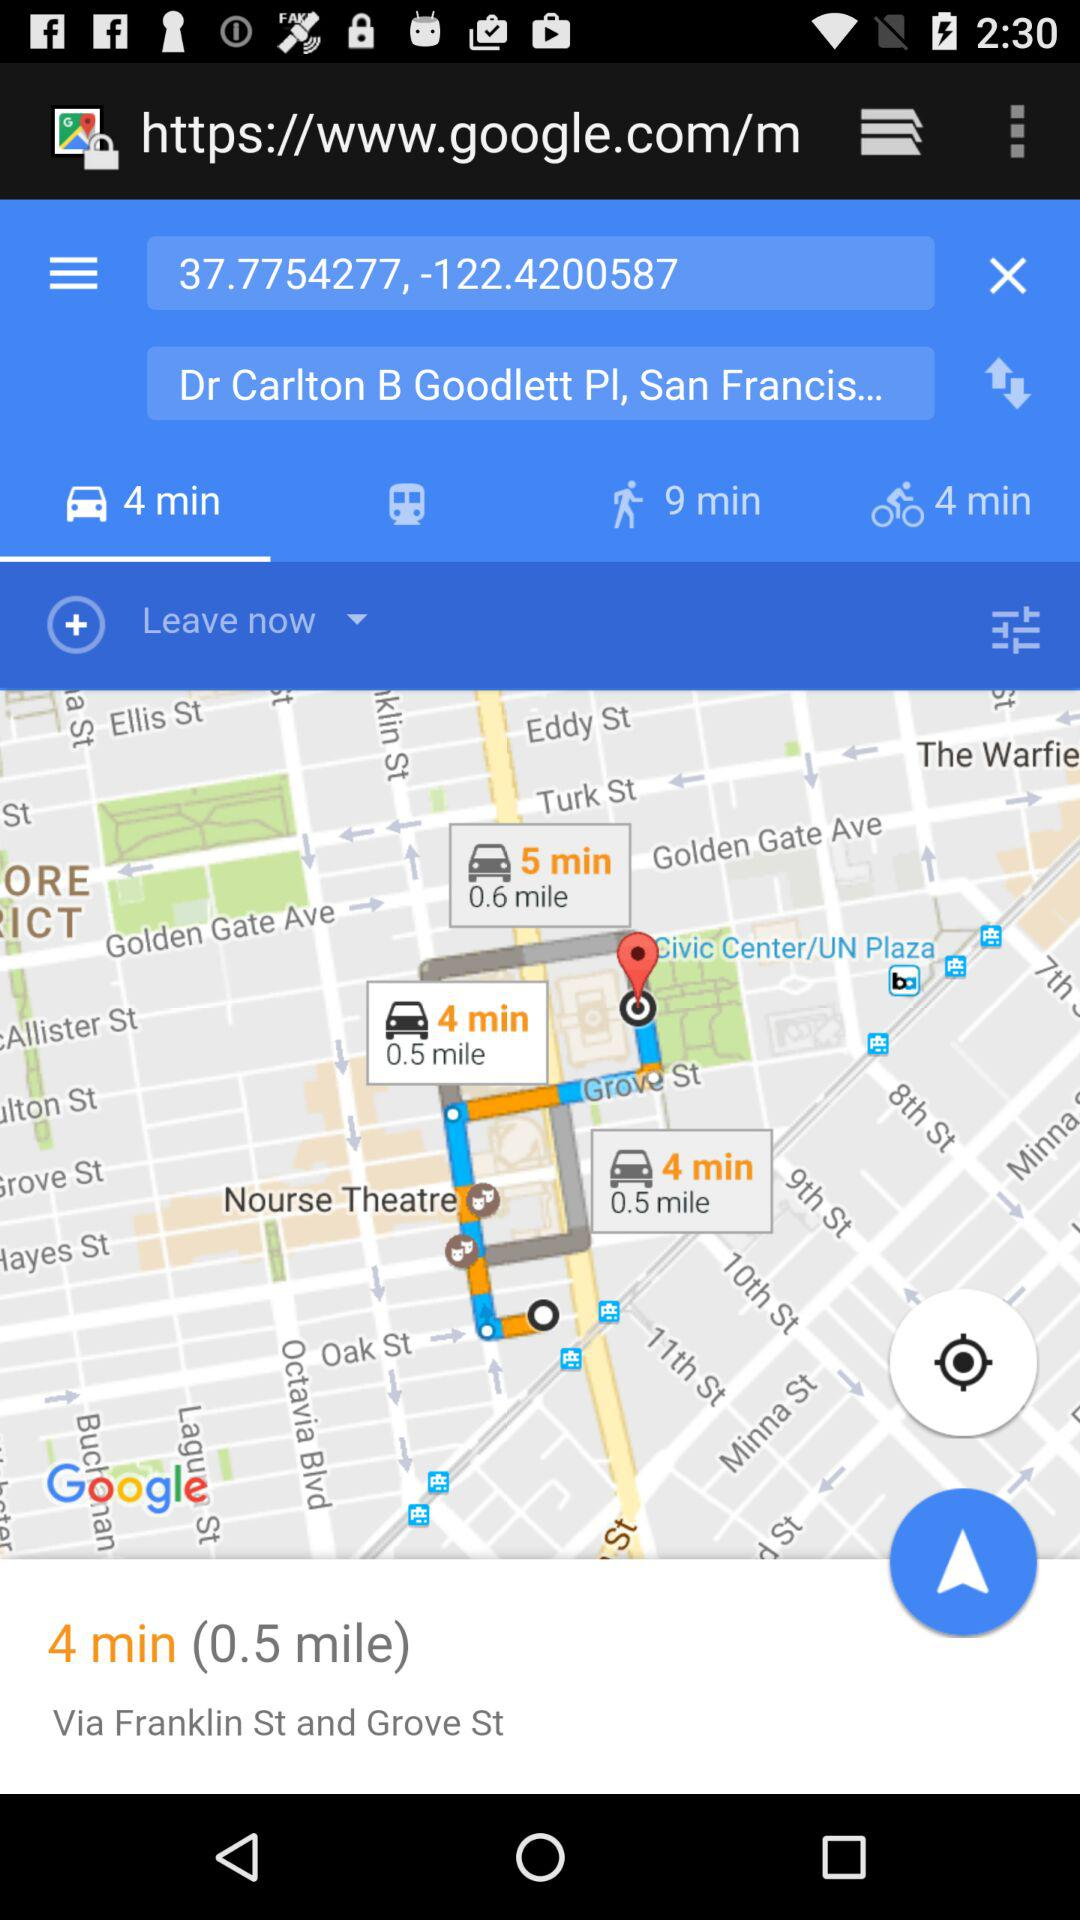How many minutes does it take to get there by bus?
When the provided information is insufficient, respond with <no answer>. <no answer> 